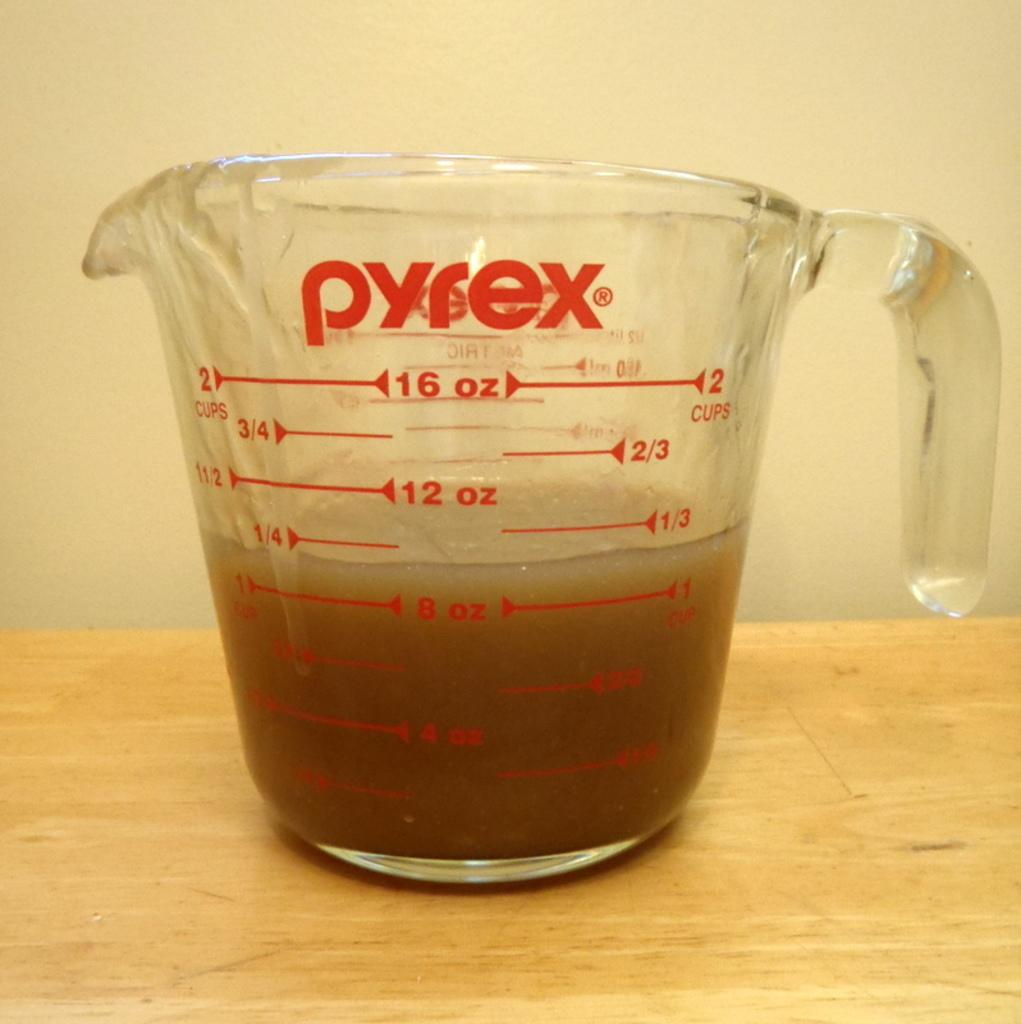<image>
Give a short and clear explanation of the subsequent image. Pyrex measuring cup that have up to two cups to measure 